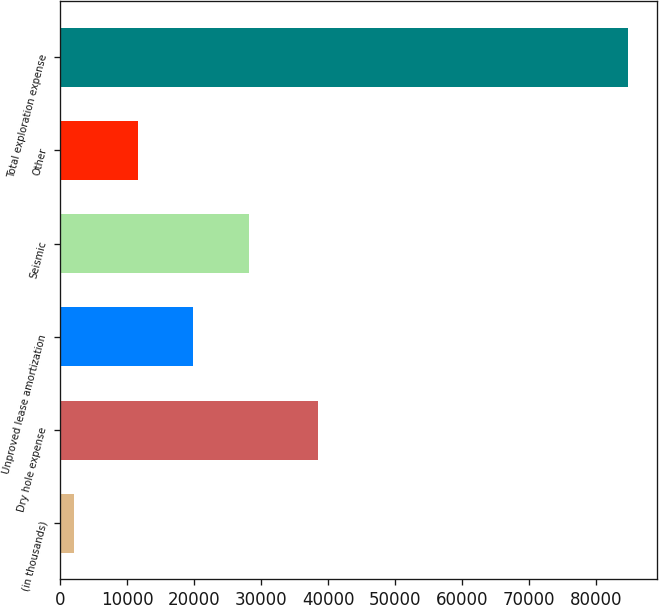Convert chart to OTSL. <chart><loc_0><loc_0><loc_500><loc_500><bar_chart><fcel>(in thousands)<fcel>Dry hole expense<fcel>Unproved lease amortization<fcel>Seismic<fcel>Other<fcel>Total exploration expense<nl><fcel>2000<fcel>38463<fcel>19878.8<fcel>28165.6<fcel>11592<fcel>84868<nl></chart> 